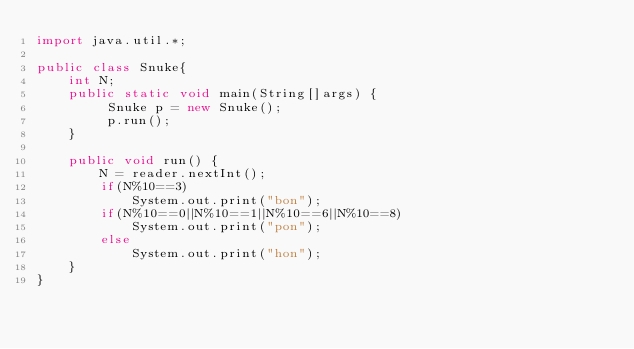<code> <loc_0><loc_0><loc_500><loc_500><_Java_>import java.util.*;

public class Snuke{
	int N;
	public static void main(String[]args) {
		 Snuke p = new Snuke();
		 p.run();
	}

	public void run() {
		N = reader.nextInt();
		if(N%10==3)
			System.out.print("bon");
		if(N%10==0||N%10==1||N%10==6||N%10==8)
			System.out.print("pon");
		else
			System.out.print("hon");
	}
}
</code> 